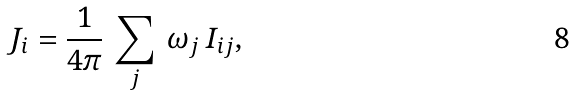Convert formula to latex. <formula><loc_0><loc_0><loc_500><loc_500>J _ { i } = \frac { 1 } { 4 \pi } \, \sum _ { j } \, \omega _ { j } \, I _ { i j } ,</formula> 